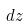<formula> <loc_0><loc_0><loc_500><loc_500>d z</formula> 